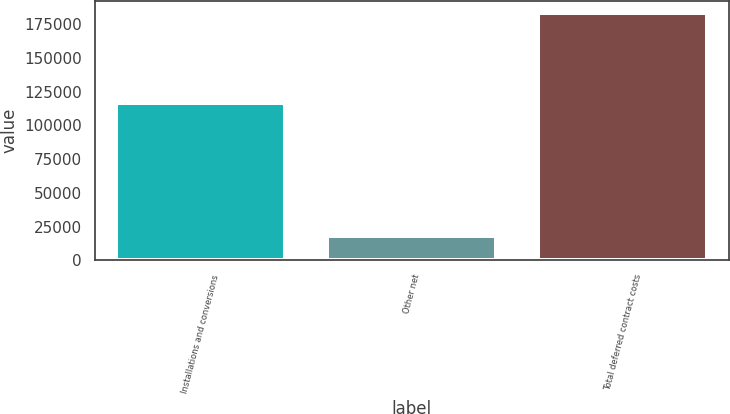<chart> <loc_0><loc_0><loc_500><loc_500><bar_chart><fcel>Installations and conversions<fcel>Other net<fcel>Total deferred contract costs<nl><fcel>116381<fcel>18308<fcel>183263<nl></chart> 